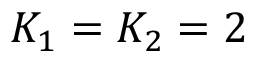<formula> <loc_0><loc_0><loc_500><loc_500>K _ { 1 } = K _ { 2 } = 2</formula> 